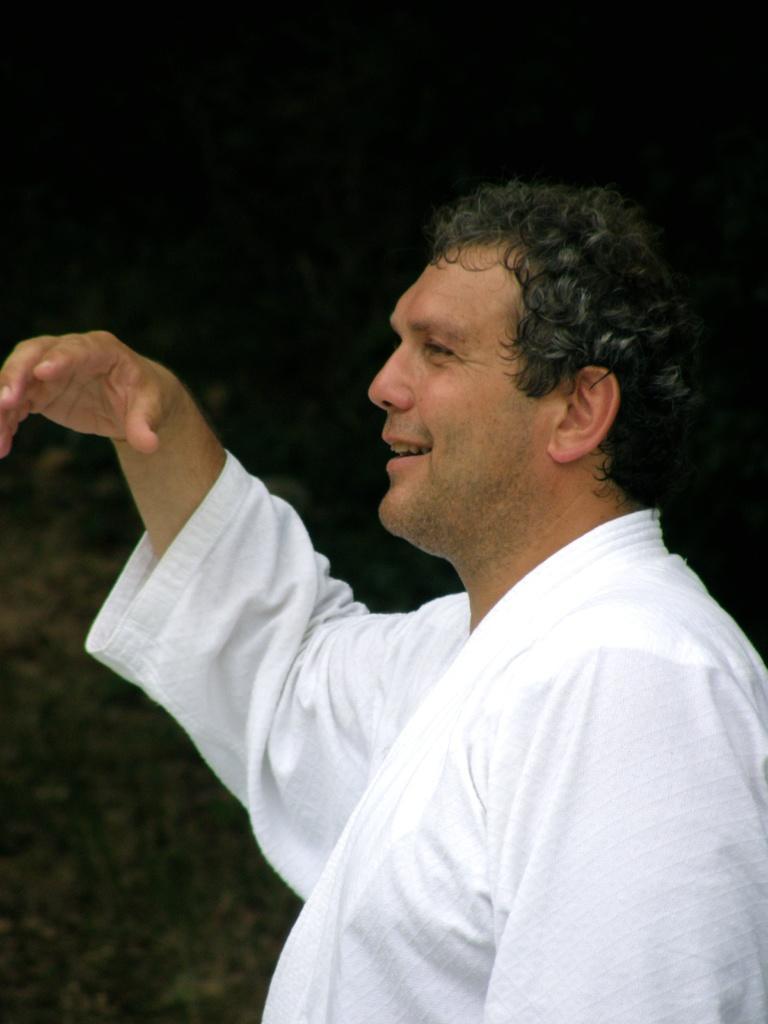Describe this image in one or two sentences. In this image a person is standing with a smiling face wearing a white dress. The background is dark. 